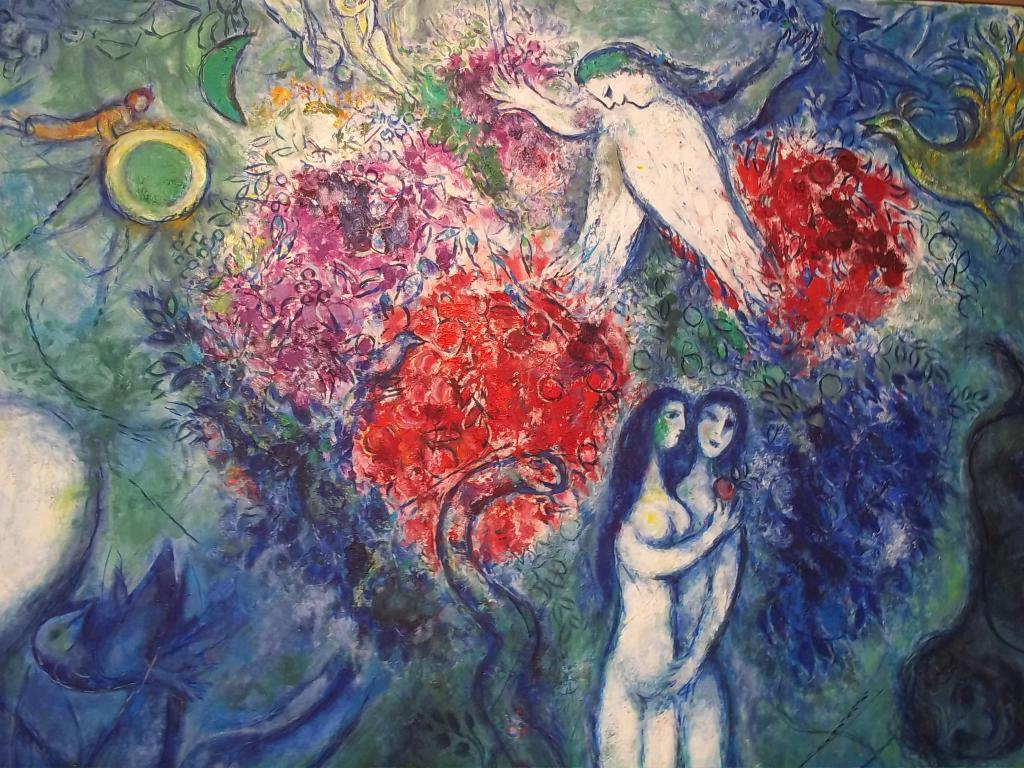What is the main subject of the image? The main subject of the image is a painting. What can be seen in the painting? The painting contains two persons, a snake, and a bird. Are there any other elements in the painting besides the persons, snake, and bird? Yes, there are other unspecified elements in the painting. What type of food is being served in the painting? There is no food present in the painting; it contains a snake, a bird, and two persons. How does the snake say good-bye to the bird in the painting? There is no interaction between the snake and the bird in the painting, nor is there any indication of a good-bye. 